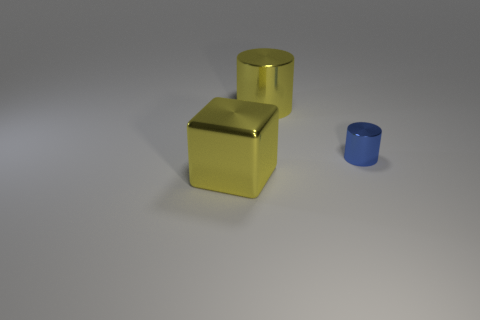Add 1 big yellow metallic cylinders. How many objects exist? 4 Subtract all cylinders. How many objects are left? 1 Add 3 tiny blue metallic things. How many tiny blue metallic things exist? 4 Subtract 0 brown cylinders. How many objects are left? 3 Subtract all small matte blocks. Subtract all yellow shiny blocks. How many objects are left? 2 Add 1 blue shiny cylinders. How many blue shiny cylinders are left? 2 